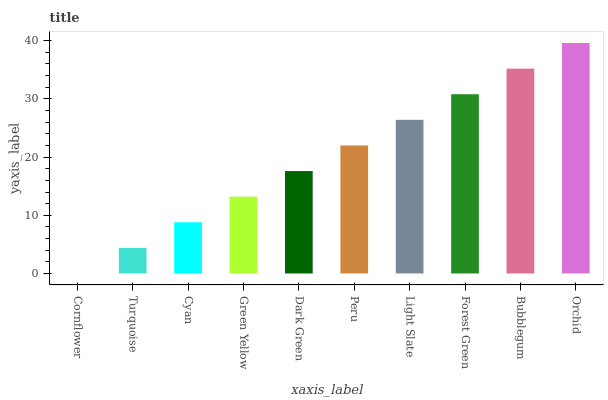Is Cornflower the minimum?
Answer yes or no. Yes. Is Orchid the maximum?
Answer yes or no. Yes. Is Turquoise the minimum?
Answer yes or no. No. Is Turquoise the maximum?
Answer yes or no. No. Is Turquoise greater than Cornflower?
Answer yes or no. Yes. Is Cornflower less than Turquoise?
Answer yes or no. Yes. Is Cornflower greater than Turquoise?
Answer yes or no. No. Is Turquoise less than Cornflower?
Answer yes or no. No. Is Peru the high median?
Answer yes or no. Yes. Is Dark Green the low median?
Answer yes or no. Yes. Is Cyan the high median?
Answer yes or no. No. Is Bubblegum the low median?
Answer yes or no. No. 